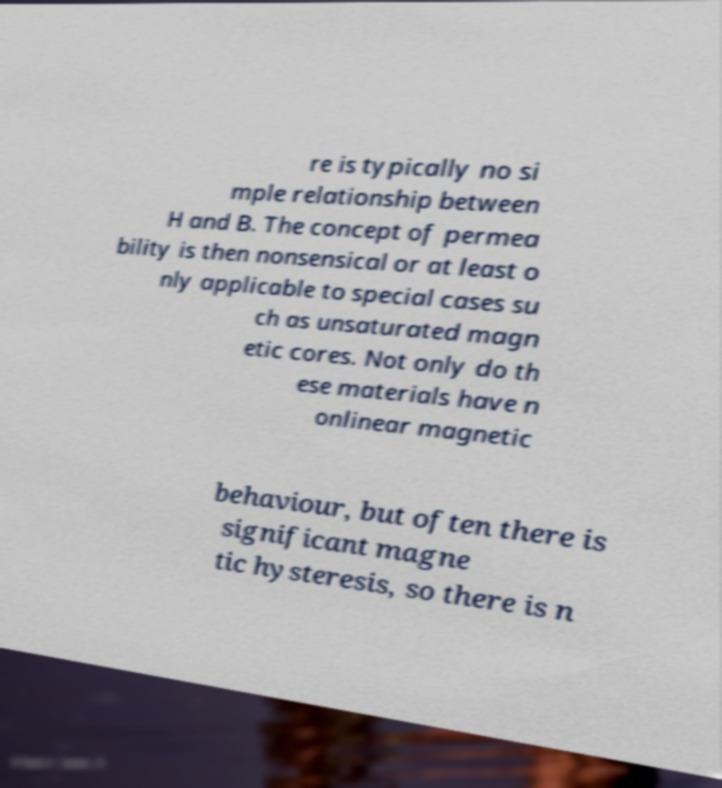I need the written content from this picture converted into text. Can you do that? re is typically no si mple relationship between H and B. The concept of permea bility is then nonsensical or at least o nly applicable to special cases su ch as unsaturated magn etic cores. Not only do th ese materials have n onlinear magnetic behaviour, but often there is significant magne tic hysteresis, so there is n 